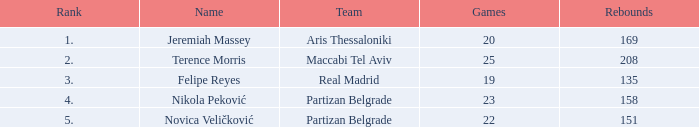What is the quantity of games played by partizan belgrade competitor nikola peković with a ranking greater than 4? None. 